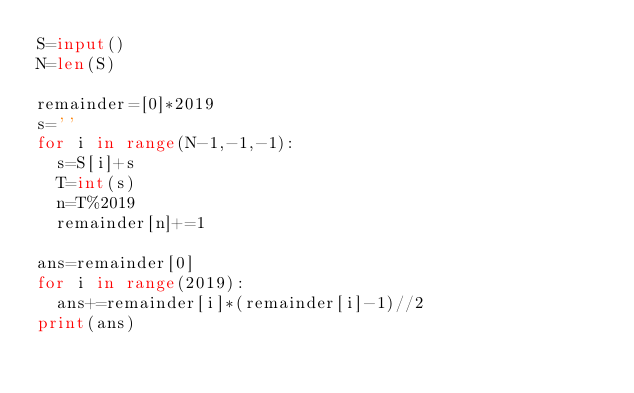<code> <loc_0><loc_0><loc_500><loc_500><_Python_>S=input()
N=len(S)

remainder=[0]*2019
s=''
for i in range(N-1,-1,-1):
  s=S[i]+s
  T=int(s)
  n=T%2019
  remainder[n]+=1

ans=remainder[0]
for i in range(2019):
  ans+=remainder[i]*(remainder[i]-1)//2
print(ans)</code> 